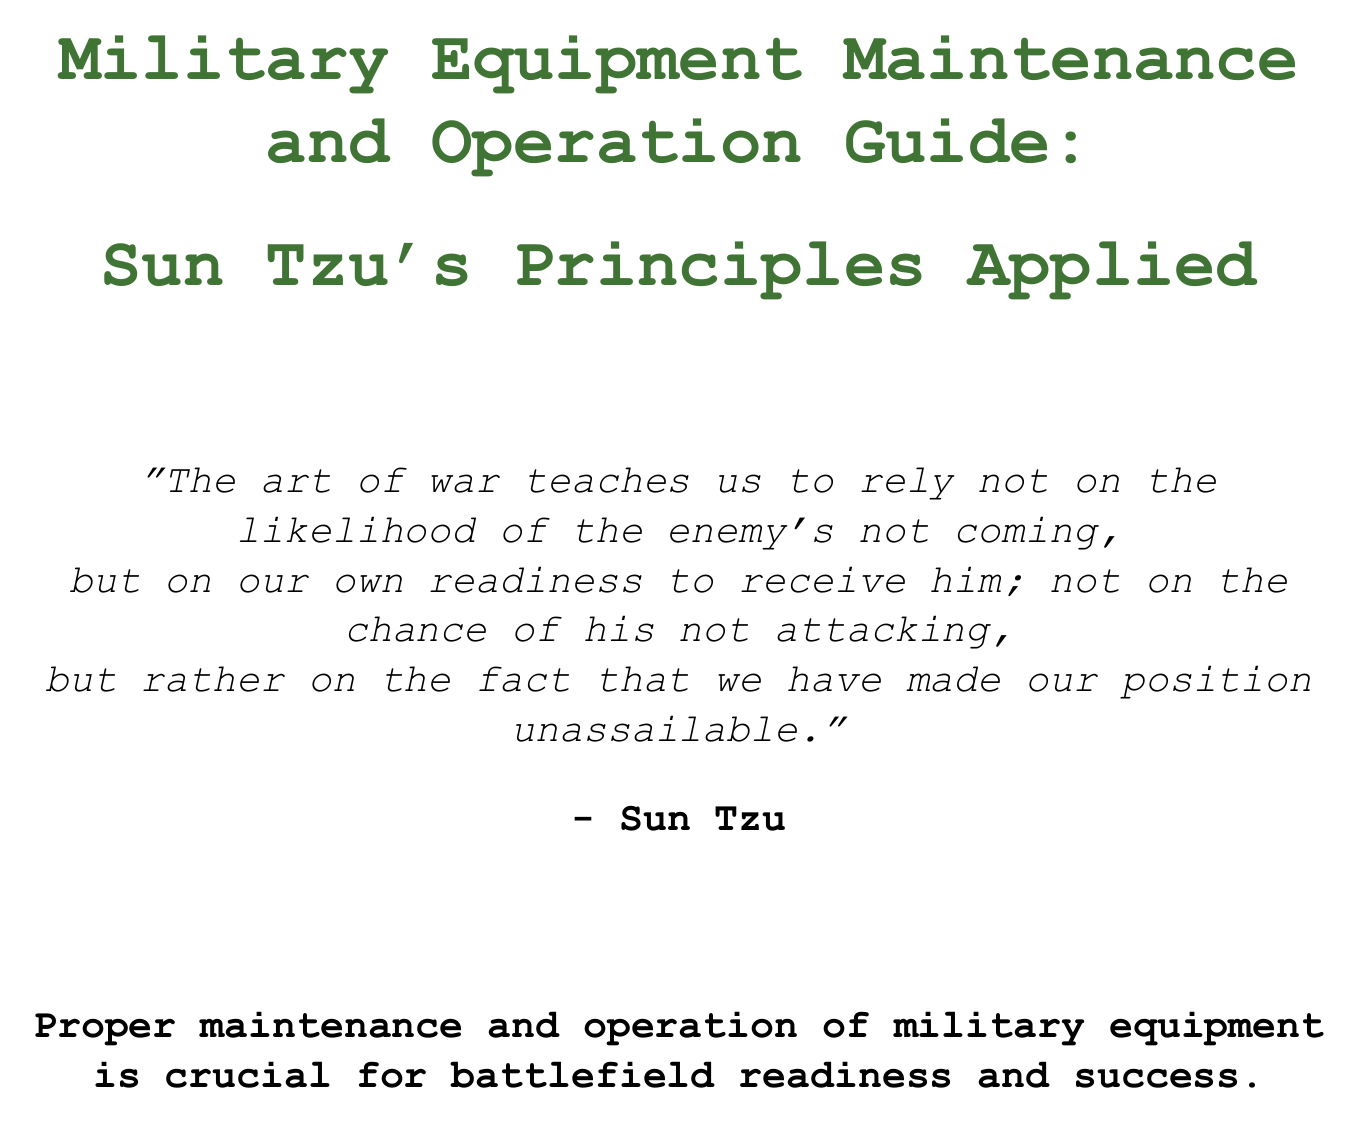What is the title of the manual? The title is provided at the beginning of the document, stating the subject and application of Sun Tzu’s principles.
Answer: Military Equipment Maintenance and Operation Guide: Sun Tzu's Principles Applied What is one of the daily maintenance tasks for the M1A2 Abrams? The document outlines specific tasks in the daily maintenance checklist for the M1A2 Abrams.
Answer: Inspect tracks How many chapters are included in the manual? The chapters section lists three distinct chapters, indicating the types of military equipment covered.
Answer: 3 What principle does Sun Tzu associate with the daily maintenance checklist? Each section relates a maintenance task to a quote from Sun Tzu to illustrate its importance.
Answer: The general who wins a battle makes many calculations in his temple before the battle is fought What is the focus of Chapter 2? This chapter covers a specific military aircraft, detailing its maintenance and operation protocols.
Answer: F-35 Lightning II Joint Strike Fighter How many sections are under Chapter 3? The chapters list the number of sections dedicated to each system, providing insight into the complexity of the subject.
Answer: 3 Which appendix provides definitions of technical terms? Each appendix is dedicated to a different aspect related to the manual's content, with one specifically focused on terminology.
Answer: Appendix B What does the quote from Sun Tzu regarding emergency protocols emphasize? The section aims to relate the importance of preparedness and effective procedures in crisis situations.
Answer: The supreme art of war is to subdue the enemy without fighting 